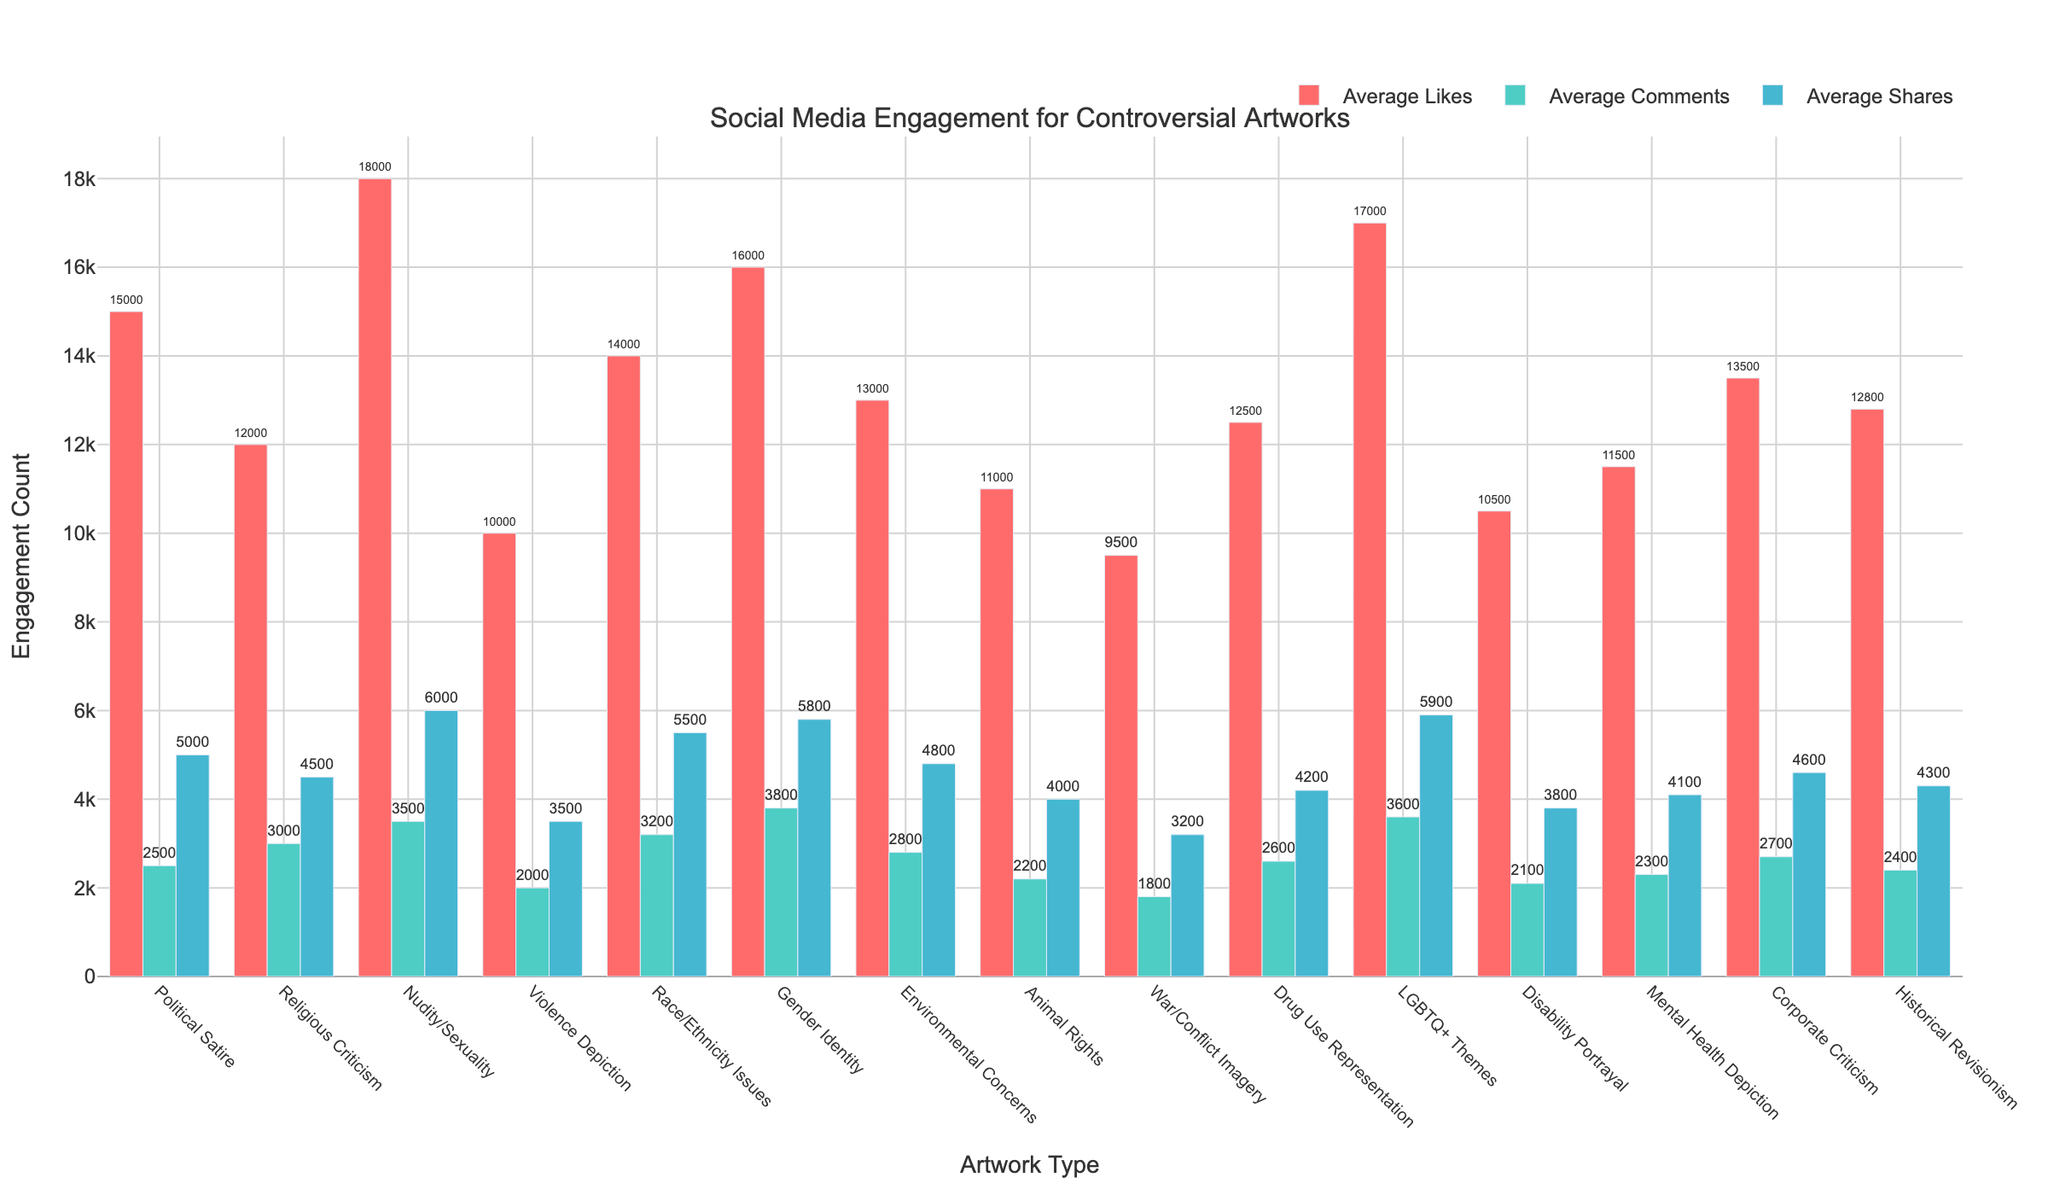Which artwork type has the highest average likes? From the figure, identify the bar that extends the farthest to the right in the "Average Likes" category.
Answer: Nudity/Sexuality Which two categories have the closest average comments? Observe the heights of the bars in the "Average Comments" section and identify the two with minimal difference.
Answer: Gender Identity and LGBTQ+ Themes How do the average shares for Gender Identity compare to Race/Ethnicity Issues? Compare the corresponding bars in the "Average Shares" section for each type. The bar for Gender Identity is slightly shorter than for Race/Ethnicity Issues.
Answer: Gender Identity has fewer shares than Race/Ethnicity Issues What is the total average engagement (likes + comments + shares) for Political Satire artwork? Sum the heights of the Political Satire bars for likes, comments, and shares using the labels on the bars: 15000 + 2500 + 5000.
Answer: 22500 Rank the top three artwork types with the highest average comments. Compare the height of the bars in the "Average Comments" section and order them from highest to lowest.
Answer: Gender Identity, LGBTQ+ Themes, Nudity/Sexuality Which artwork type has the lowest average engagement in total? Sum the values of the likes, comments, and shares for all types and identify the minimum sum. Calculate for War/Conflict Imagery: 9500 + 1800 + 3200 = 14500, and compare with others.
Answer: War/Conflict Imagery How much more are the average likes for Mental Health Depiction than for War/Conflict Imagery? Subtract the height of the likes bar for War/Conflict Imagery from that of Mental Health Depiction (11500 - 9500).
Answer: 2000 What is the average number of shares across all artwork types? Sum the "Average Shares" for all types and divide by the number of types. Multiply the average counts by the number of categories, then add: (5000 + 4500 + 6000 + 3500 + 5500 + 5800 + 4800 + 4000 + 3200 + 4200 + 5900 + 3800 + 4100 + 4600 + 4300)/15.
Answer: 4740 